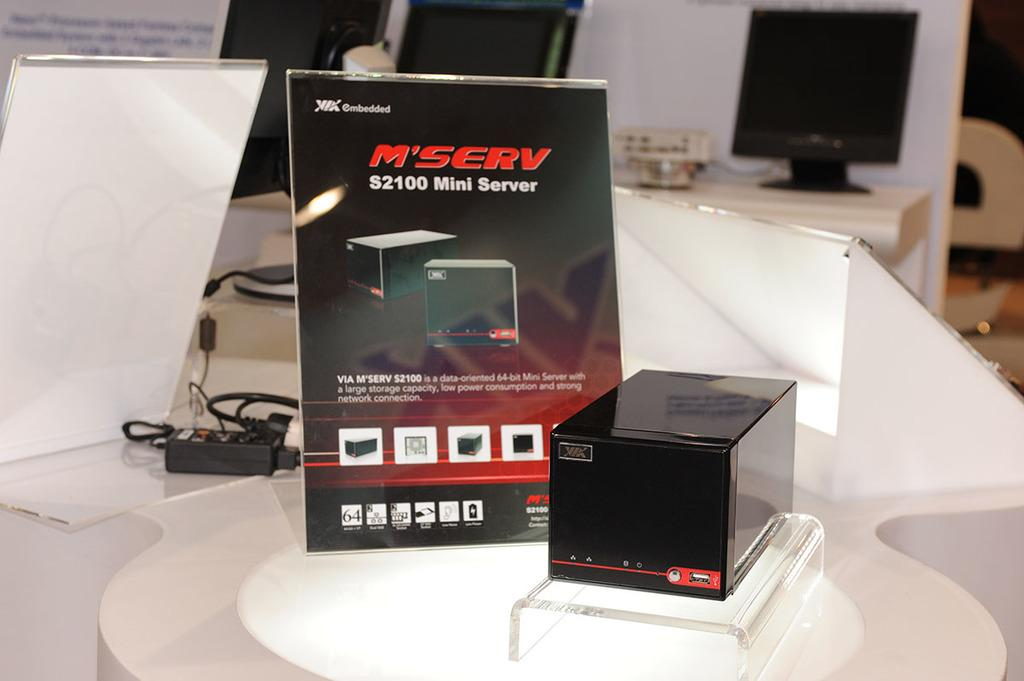<image>
Write a terse but informative summary of the picture. A sign for the S2100 Mini Server sits behind the product itself. 